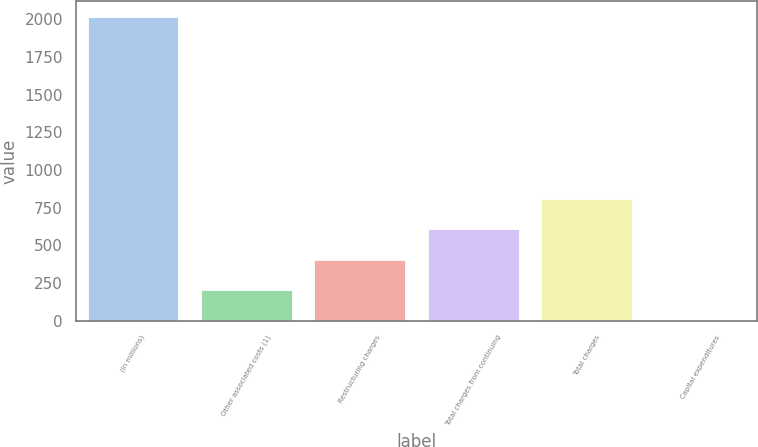<chart> <loc_0><loc_0><loc_500><loc_500><bar_chart><fcel>(In millions)<fcel>Other associated costs (1)<fcel>Restructuring charges<fcel>Total charges from continuing<fcel>Total charges<fcel>Capital expenditures<nl><fcel>2018<fcel>202.7<fcel>404.4<fcel>606.1<fcel>807.8<fcel>1<nl></chart> 